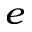Convert formula to latex. <formula><loc_0><loc_0><loc_500><loc_500>_ { e }</formula> 